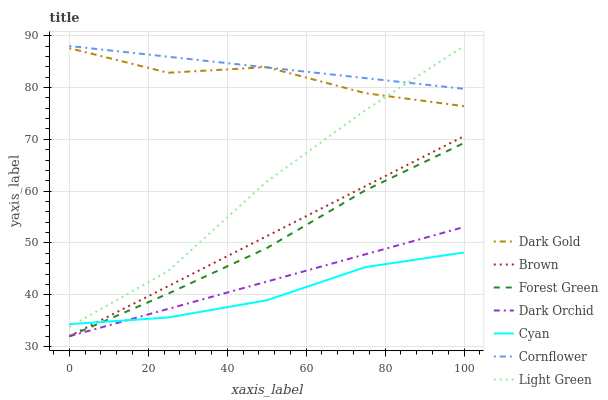Does Cyan have the minimum area under the curve?
Answer yes or no. Yes. Does Cornflower have the maximum area under the curve?
Answer yes or no. Yes. Does Dark Gold have the minimum area under the curve?
Answer yes or no. No. Does Dark Gold have the maximum area under the curve?
Answer yes or no. No. Is Cornflower the smoothest?
Answer yes or no. Yes. Is Dark Gold the roughest?
Answer yes or no. Yes. Is Dark Gold the smoothest?
Answer yes or no. No. Is Cornflower the roughest?
Answer yes or no. No. Does Brown have the lowest value?
Answer yes or no. Yes. Does Dark Gold have the lowest value?
Answer yes or no. No. Does Light Green have the highest value?
Answer yes or no. Yes. Does Dark Gold have the highest value?
Answer yes or no. No. Is Cyan less than Dark Gold?
Answer yes or no. Yes. Is Light Green greater than Brown?
Answer yes or no. Yes. Does Brown intersect Forest Green?
Answer yes or no. Yes. Is Brown less than Forest Green?
Answer yes or no. No. Is Brown greater than Forest Green?
Answer yes or no. No. Does Cyan intersect Dark Gold?
Answer yes or no. No. 